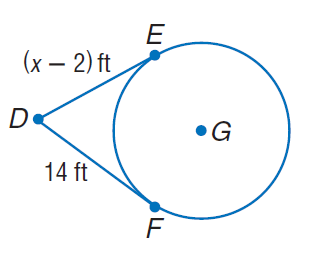Answer the mathemtical geometry problem and directly provide the correct option letter.
Question: Find x. Assume that segments that appear to be tangent are tangent.
Choices: A: 14 B: 15 C: 16 D: 17 C 